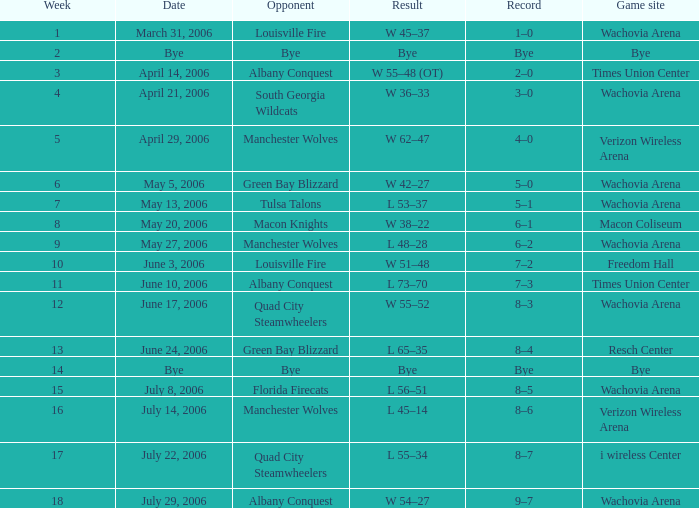What is the result for the game on May 27, 2006? L 48–28. 